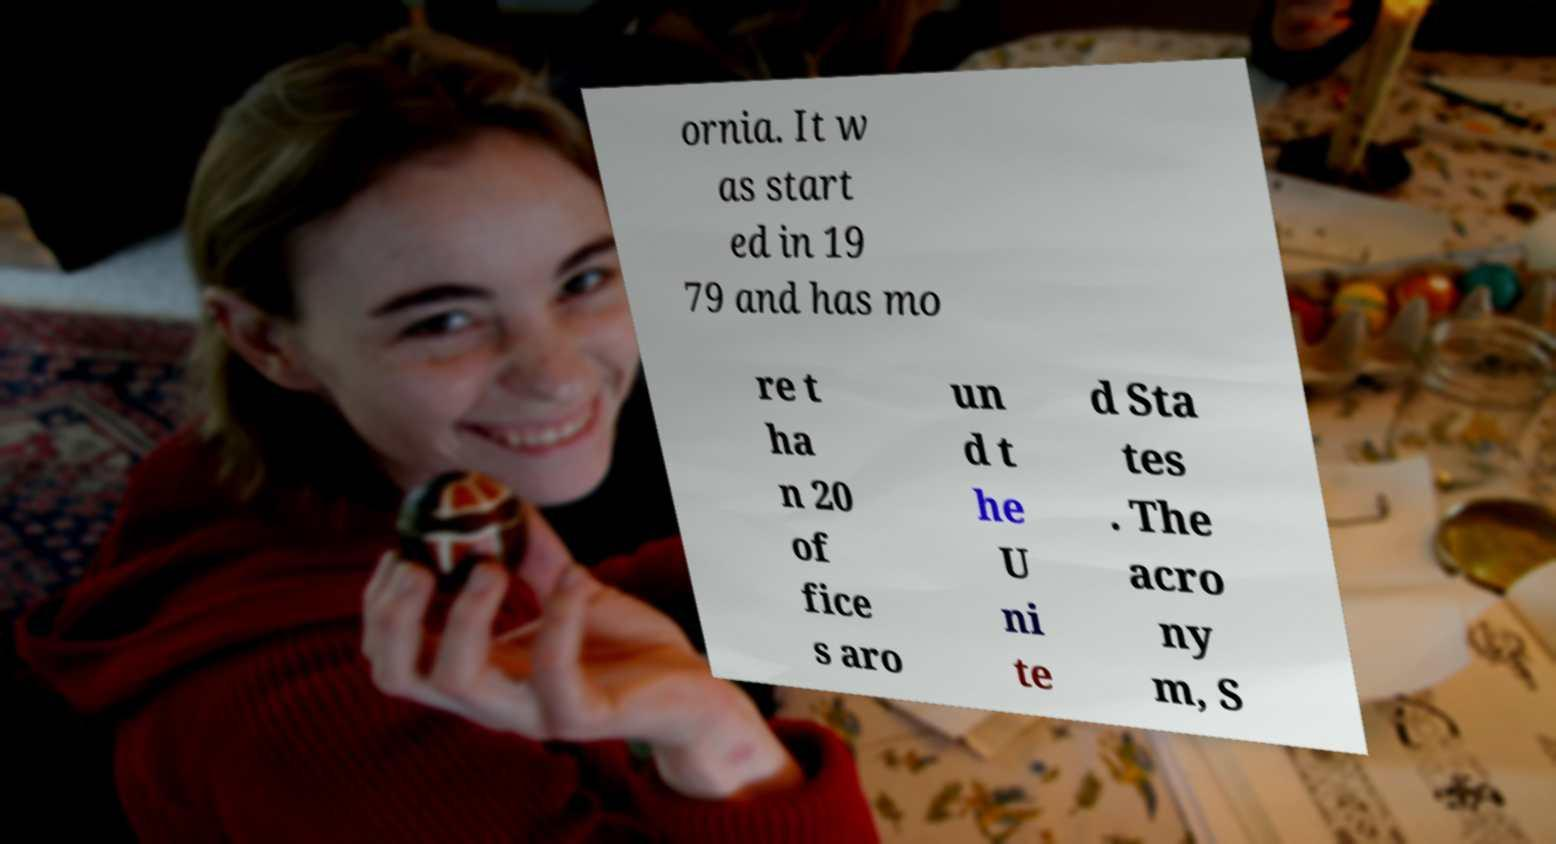Please identify and transcribe the text found in this image. ornia. It w as start ed in 19 79 and has mo re t ha n 20 of fice s aro un d t he U ni te d Sta tes . The acro ny m, S 